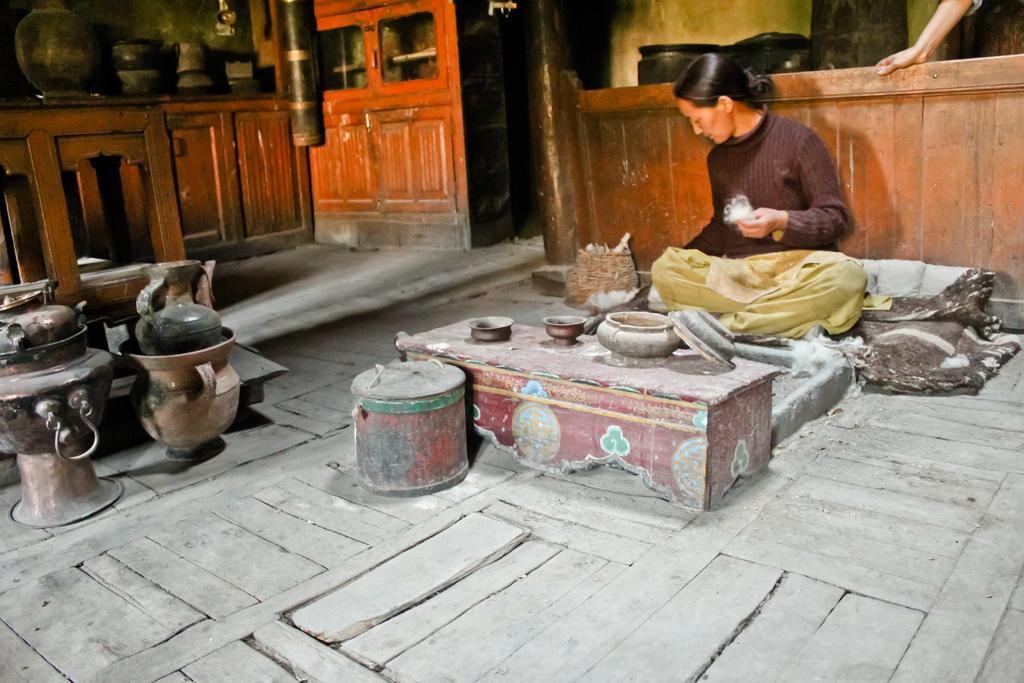Please provide a concise description of this image. In this image, I can see a woman sitting. In front of the women, there are bowls and a lid on a table and I can see a container on the wooden floor. On the left side of the image, I can see utensils and a wooden object. In the background, I can see a pot, few other utensils and cupboards. Behind the woman, I can see a wooden wall and few other objects. In the top right corner of the image, I can see a person's hand. 